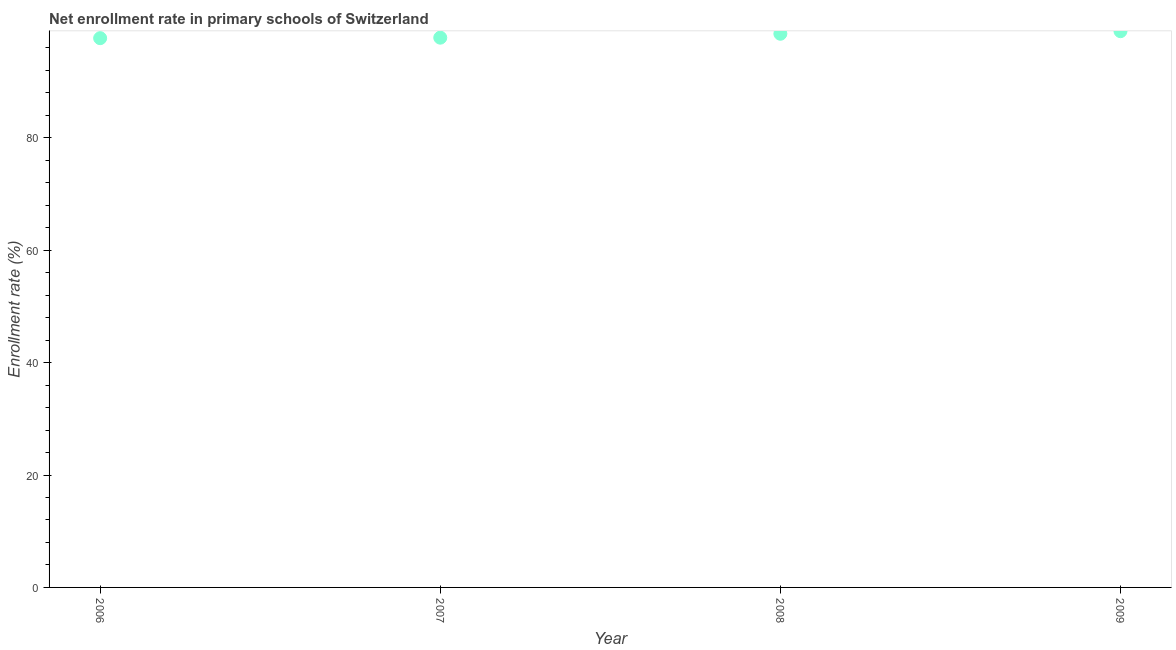What is the net enrollment rate in primary schools in 2009?
Keep it short and to the point. 98.96. Across all years, what is the maximum net enrollment rate in primary schools?
Your response must be concise. 98.96. Across all years, what is the minimum net enrollment rate in primary schools?
Provide a short and direct response. 97.72. In which year was the net enrollment rate in primary schools maximum?
Offer a terse response. 2009. In which year was the net enrollment rate in primary schools minimum?
Keep it short and to the point. 2006. What is the sum of the net enrollment rate in primary schools?
Keep it short and to the point. 392.99. What is the difference between the net enrollment rate in primary schools in 2006 and 2007?
Your answer should be compact. -0.09. What is the average net enrollment rate in primary schools per year?
Provide a short and direct response. 98.25. What is the median net enrollment rate in primary schools?
Ensure brevity in your answer.  98.15. Do a majority of the years between 2009 and 2006 (inclusive) have net enrollment rate in primary schools greater than 80 %?
Your answer should be compact. Yes. What is the ratio of the net enrollment rate in primary schools in 2008 to that in 2009?
Make the answer very short. 1. What is the difference between the highest and the second highest net enrollment rate in primary schools?
Your answer should be compact. 0.46. Is the sum of the net enrollment rate in primary schools in 2006 and 2007 greater than the maximum net enrollment rate in primary schools across all years?
Your answer should be compact. Yes. What is the difference between the highest and the lowest net enrollment rate in primary schools?
Your response must be concise. 1.24. What is the difference between two consecutive major ticks on the Y-axis?
Your answer should be very brief. 20. What is the title of the graph?
Keep it short and to the point. Net enrollment rate in primary schools of Switzerland. What is the label or title of the Y-axis?
Offer a very short reply. Enrollment rate (%). What is the Enrollment rate (%) in 2006?
Keep it short and to the point. 97.72. What is the Enrollment rate (%) in 2007?
Give a very brief answer. 97.81. What is the Enrollment rate (%) in 2008?
Make the answer very short. 98.5. What is the Enrollment rate (%) in 2009?
Your response must be concise. 98.96. What is the difference between the Enrollment rate (%) in 2006 and 2007?
Make the answer very short. -0.09. What is the difference between the Enrollment rate (%) in 2006 and 2008?
Your answer should be compact. -0.78. What is the difference between the Enrollment rate (%) in 2006 and 2009?
Give a very brief answer. -1.24. What is the difference between the Enrollment rate (%) in 2007 and 2008?
Your answer should be compact. -0.7. What is the difference between the Enrollment rate (%) in 2007 and 2009?
Your answer should be compact. -1.16. What is the difference between the Enrollment rate (%) in 2008 and 2009?
Provide a short and direct response. -0.46. What is the ratio of the Enrollment rate (%) in 2006 to that in 2008?
Give a very brief answer. 0.99. What is the ratio of the Enrollment rate (%) in 2006 to that in 2009?
Make the answer very short. 0.99. What is the ratio of the Enrollment rate (%) in 2007 to that in 2008?
Your answer should be compact. 0.99. What is the ratio of the Enrollment rate (%) in 2007 to that in 2009?
Provide a succinct answer. 0.99. 